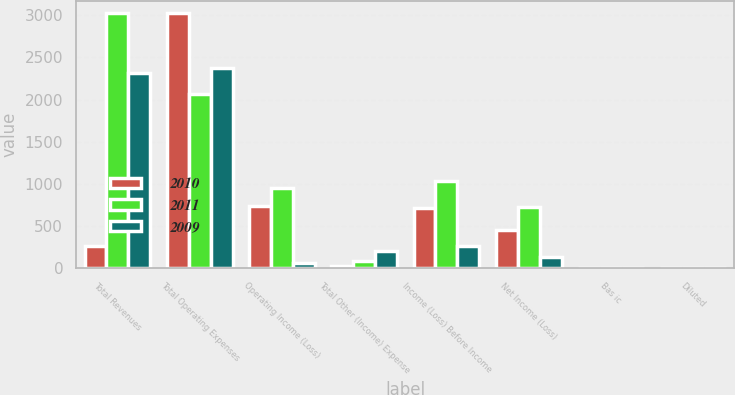<chart> <loc_0><loc_0><loc_500><loc_500><stacked_bar_chart><ecel><fcel>Total Revenues<fcel>Total Operating Expenses<fcel>Operating Income (Loss)<fcel>Total Other (Income) Expense<fcel>Income (Loss) Before Income<fcel>Net Income (Loss)<fcel>Bas ic<fcel>Diluted<nl><fcel>2010<fcel>264<fcel>3023<fcel>740<fcel>25<fcel>715<fcel>453<fcel>2.57<fcel>2.54<nl><fcel>2011<fcel>3022<fcel>2070<fcel>952<fcel>79<fcel>1031<fcel>725<fcel>4.15<fcel>4.1<nl><fcel>2009<fcel>2313<fcel>2371<fcel>58<fcel>206<fcel>264<fcel>131<fcel>0.75<fcel>0.75<nl></chart> 